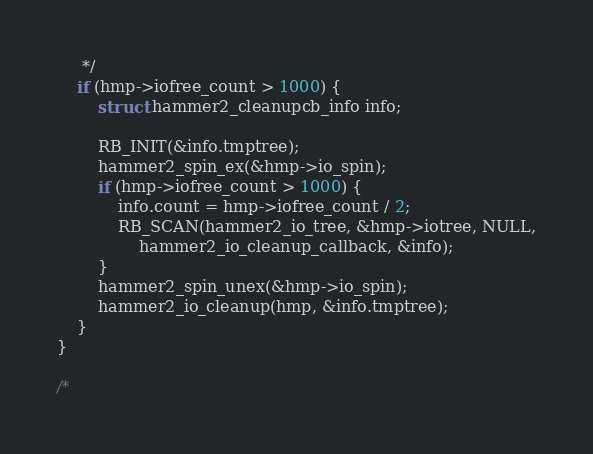<code> <loc_0><loc_0><loc_500><loc_500><_C_>	 */
	if (hmp->iofree_count > 1000) {
		struct hammer2_cleanupcb_info info;

		RB_INIT(&info.tmptree);
		hammer2_spin_ex(&hmp->io_spin);
		if (hmp->iofree_count > 1000) {
			info.count = hmp->iofree_count / 2;
			RB_SCAN(hammer2_io_tree, &hmp->iotree, NULL,
				hammer2_io_cleanup_callback, &info);
		}
		hammer2_spin_unex(&hmp->io_spin);
		hammer2_io_cleanup(hmp, &info.tmptree);
	}
}

/*</code> 